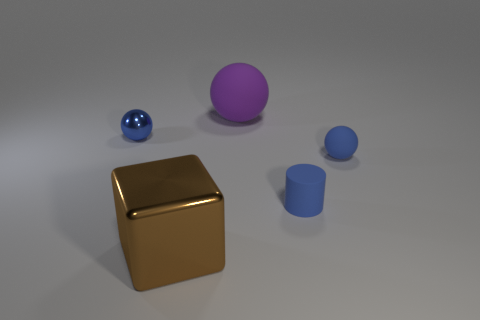Is the shape of the small metal object the same as the big brown metallic thing?
Offer a terse response. No. How many blue things are in front of the tiny blue shiny ball?
Make the answer very short. 2. Is the color of the small object left of the large shiny thing the same as the small rubber cylinder?
Offer a terse response. Yes. What number of purple matte objects are the same size as the brown metal thing?
Offer a terse response. 1. The other small thing that is made of the same material as the brown thing is what shape?
Provide a short and direct response. Sphere. Is there a cylinder that has the same color as the small metal sphere?
Offer a terse response. Yes. What is the material of the purple thing?
Your answer should be compact. Rubber. What number of objects are small blue rubber cylinders or green spheres?
Your response must be concise. 1. What is the size of the ball that is on the left side of the large metallic cube?
Your answer should be compact. Small. How many other things are the same material as the small blue cylinder?
Your answer should be compact. 2. 